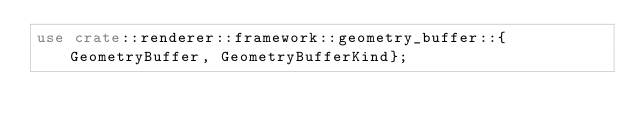Convert code to text. <code><loc_0><loc_0><loc_500><loc_500><_Rust_>use crate::renderer::framework::geometry_buffer::{GeometryBuffer, GeometryBufferKind};</code> 